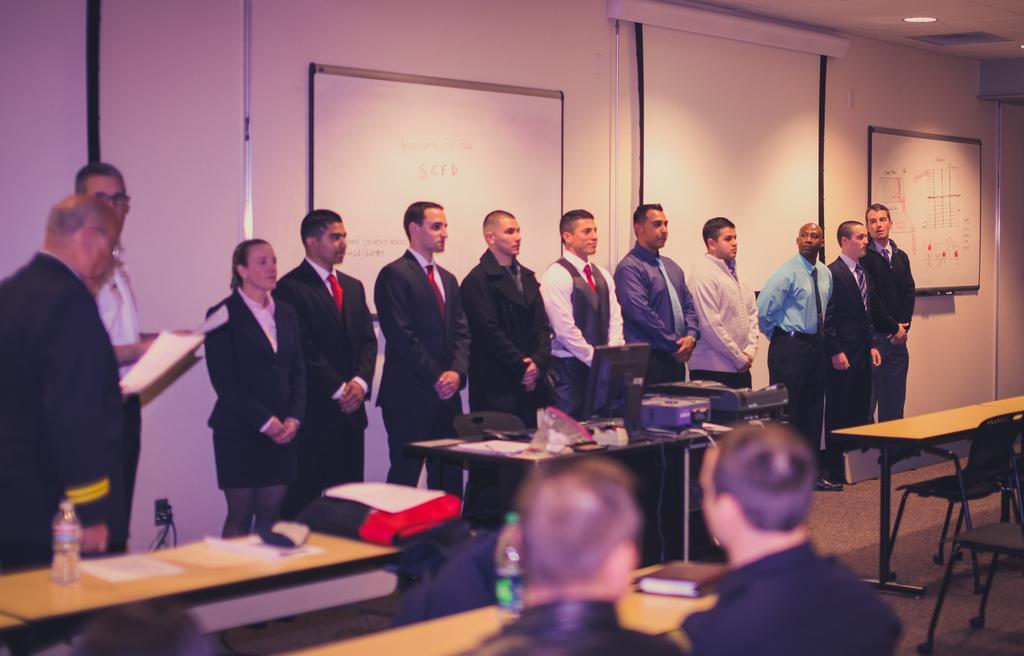Could you give a brief overview of what you see in this image? It looks like a meeting hall ,there are many people standing in front of the room behind them there are two projecting screens, in front of them there is a monitor on the table,in the background there is a white color wall. 